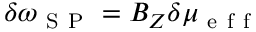Convert formula to latex. <formula><loc_0><loc_0><loc_500><loc_500>\delta \omega _ { S P } = B _ { Z } \delta \mu _ { e f f }</formula> 